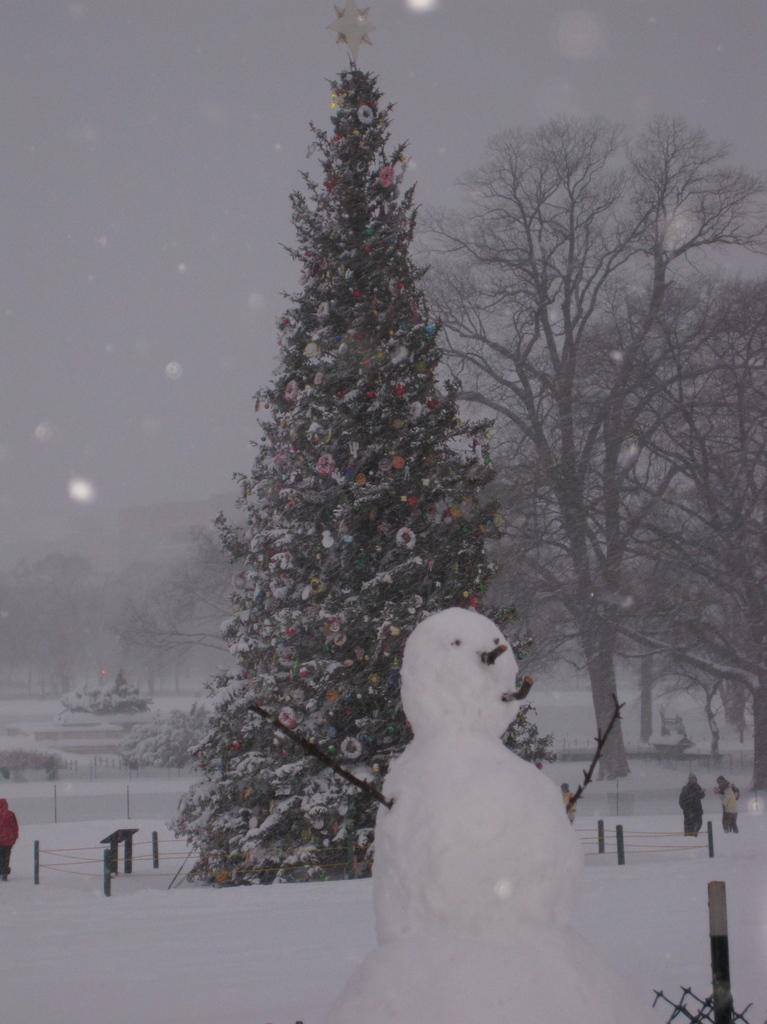What is the main subject in the center of the image? There is a Christmas tree and a snowman in the center of the image. What type of environment is depicted in the image? The image shows a snowy environment, with snow in the background. What can be seen in the background of the image? There are trees and the sky visible in the background of the image. How long does it take for the vessel to laugh in the image? There is no vessel or laughter present in the image. What type of minute is shown in the image? There is no minute depicted in the image; it features a Christmas tree, a snowman, and a snowy environment. 